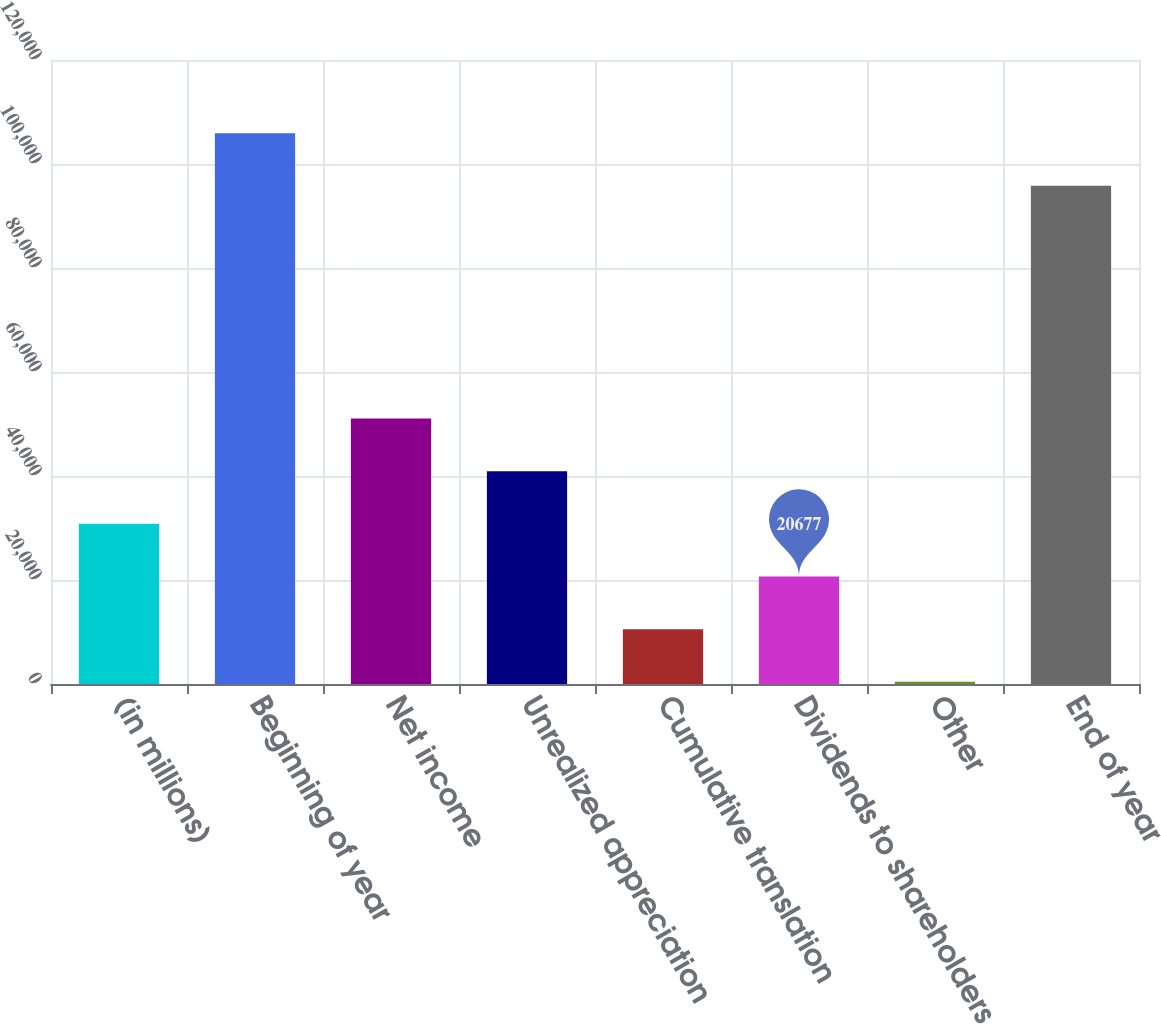Convert chart. <chart><loc_0><loc_0><loc_500><loc_500><bar_chart><fcel>(in millions)<fcel>Beginning of year<fcel>Net income<fcel>Unrealized appreciation<fcel>Cumulative translation<fcel>Dividends to shareholders<fcel>Other<fcel>End of year<nl><fcel>30802<fcel>105926<fcel>51052<fcel>40927<fcel>10552<fcel>20677<fcel>427<fcel>95801<nl></chart> 